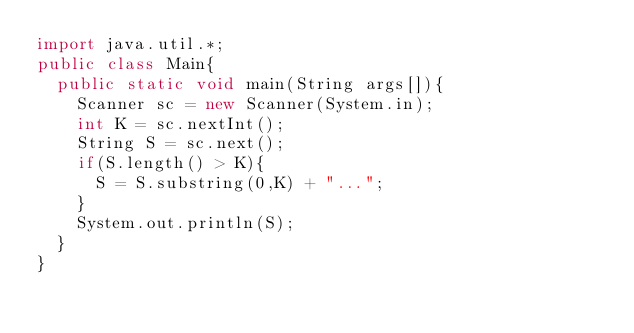<code> <loc_0><loc_0><loc_500><loc_500><_Java_>import java.util.*;
public class Main{
	public static void main(String args[]){
		Scanner sc = new Scanner(System.in);
		int K = sc.nextInt();
		String S = sc.next();
		if(S.length() > K){
			S = S.substring(0,K) + "...";
		}
		System.out.println(S);
	}
}</code> 